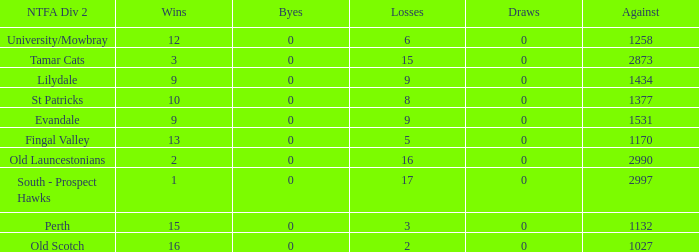What is the lowest number of against of NTFA Div 2 Fingal Valley? 1170.0. 